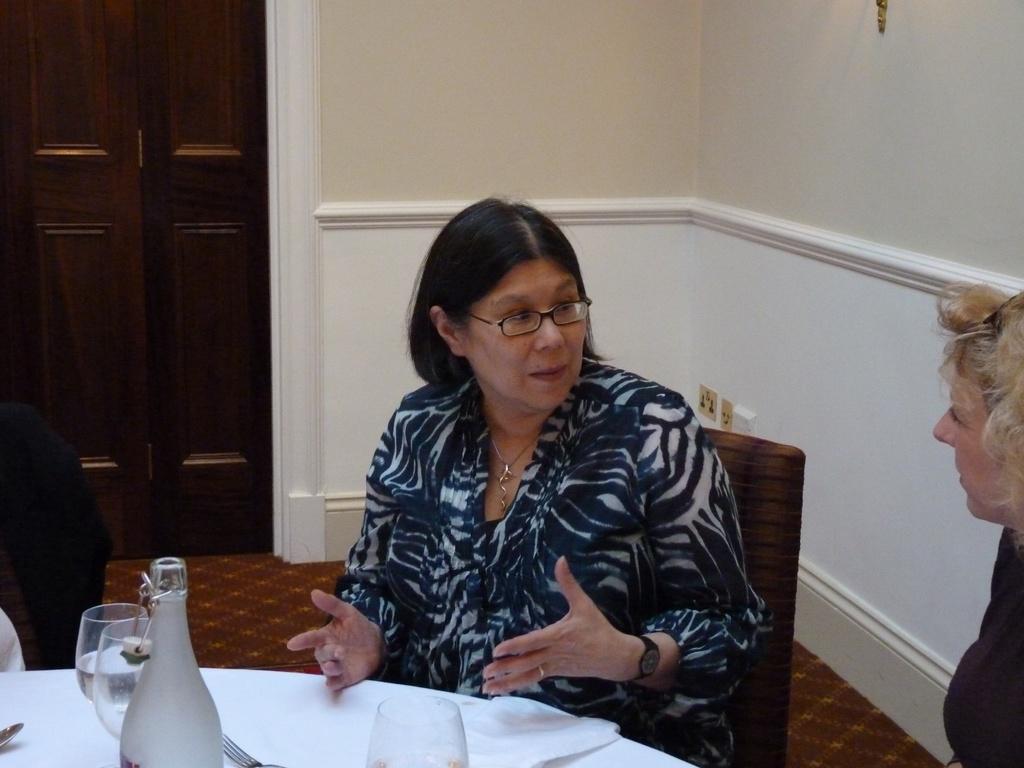Can you describe this image briefly? The image is inside the room, In the image there are two people sitting on chair in front of a table, on table we can see a cloth,glass,paper,bottle,fork,spoon. In background we can see a door which is closed and a wall which is in white color. 